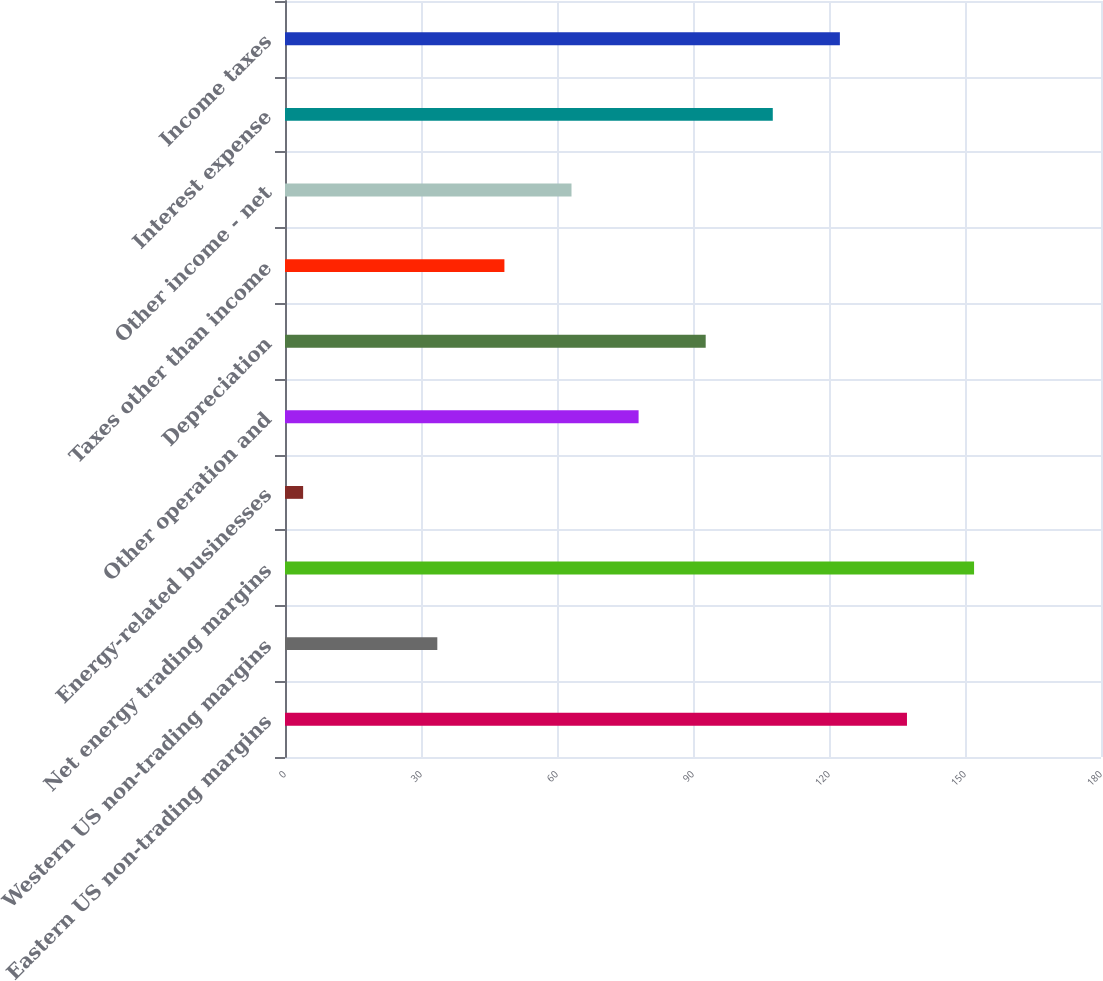Convert chart. <chart><loc_0><loc_0><loc_500><loc_500><bar_chart><fcel>Eastern US non-trading margins<fcel>Western US non-trading margins<fcel>Net energy trading margins<fcel>Energy-related businesses<fcel>Other operation and<fcel>Depreciation<fcel>Taxes other than income<fcel>Other income - net<fcel>Interest expense<fcel>Income taxes<nl><fcel>137.2<fcel>33.6<fcel>152<fcel>4<fcel>78<fcel>92.8<fcel>48.4<fcel>63.2<fcel>107.6<fcel>122.4<nl></chart> 